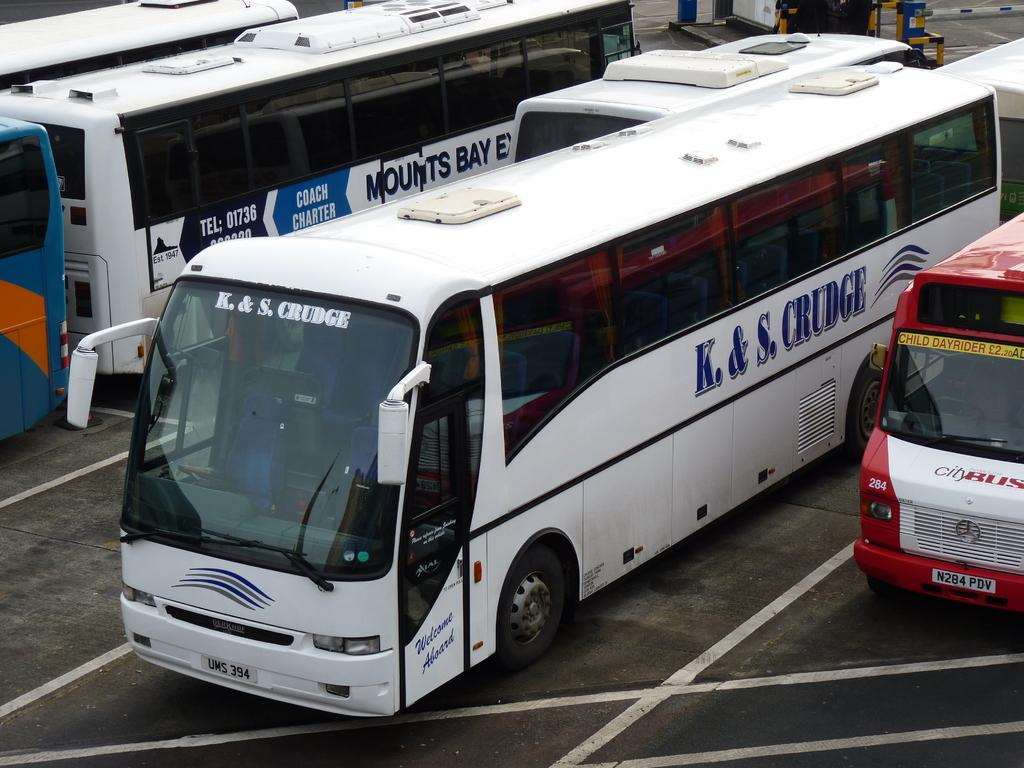<image>
Offer a succinct explanation of the picture presented. The white bus in the middle is from K&S. Krudge. 